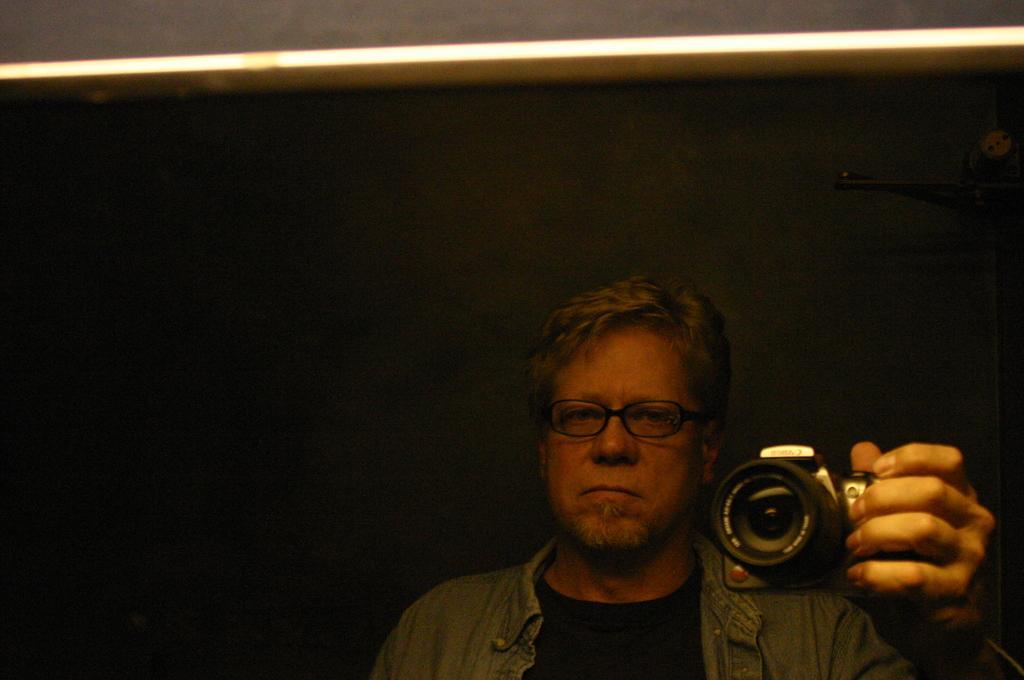How would you summarize this image in a sentence or two? He is holding a camera. He's wearing a spectacle. His look at a side. 